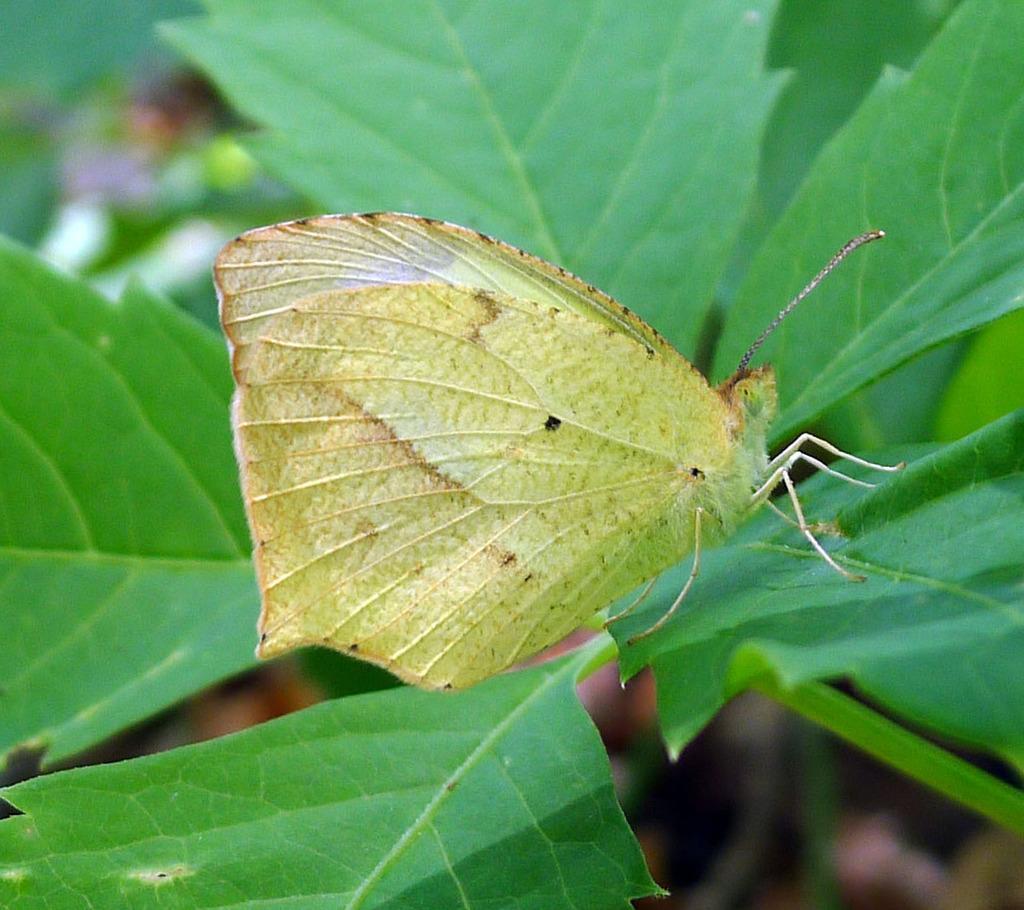Can you describe this image briefly? In this picture, we see a butterfly. The butterfly in yellow color is on the green leaf. Beside that, we see a plant or a tree. In the background, it is green in color and it is blurred in the background. 